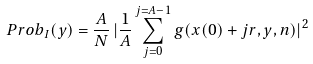Convert formula to latex. <formula><loc_0><loc_0><loc_500><loc_500>P r o b _ { I } ( y ) = \frac { A } { N } \, | \frac { 1 } { A } \sum _ { j = 0 } ^ { j = A - 1 } g ( x ( 0 ) + j r , y , n ) | ^ { 2 }</formula> 